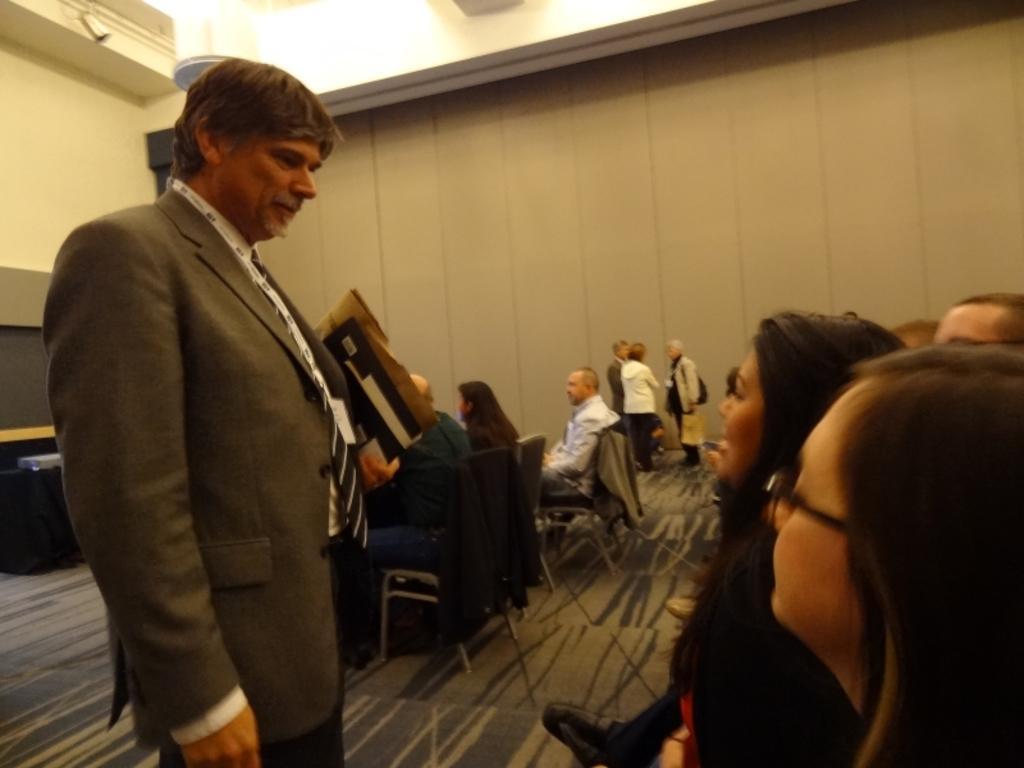In one or two sentences, can you explain what this image depicts? In front of the image there is a person standing by holding some objects in his hand, in front of the person there are a few other people sitting in chairs, beside the person there are a few other people sitting in chairs and there are a few people standing, behind the person there are some objects on the table. In the background of the image there is a wall. At the top of the image there is a camera on the rooftop. 